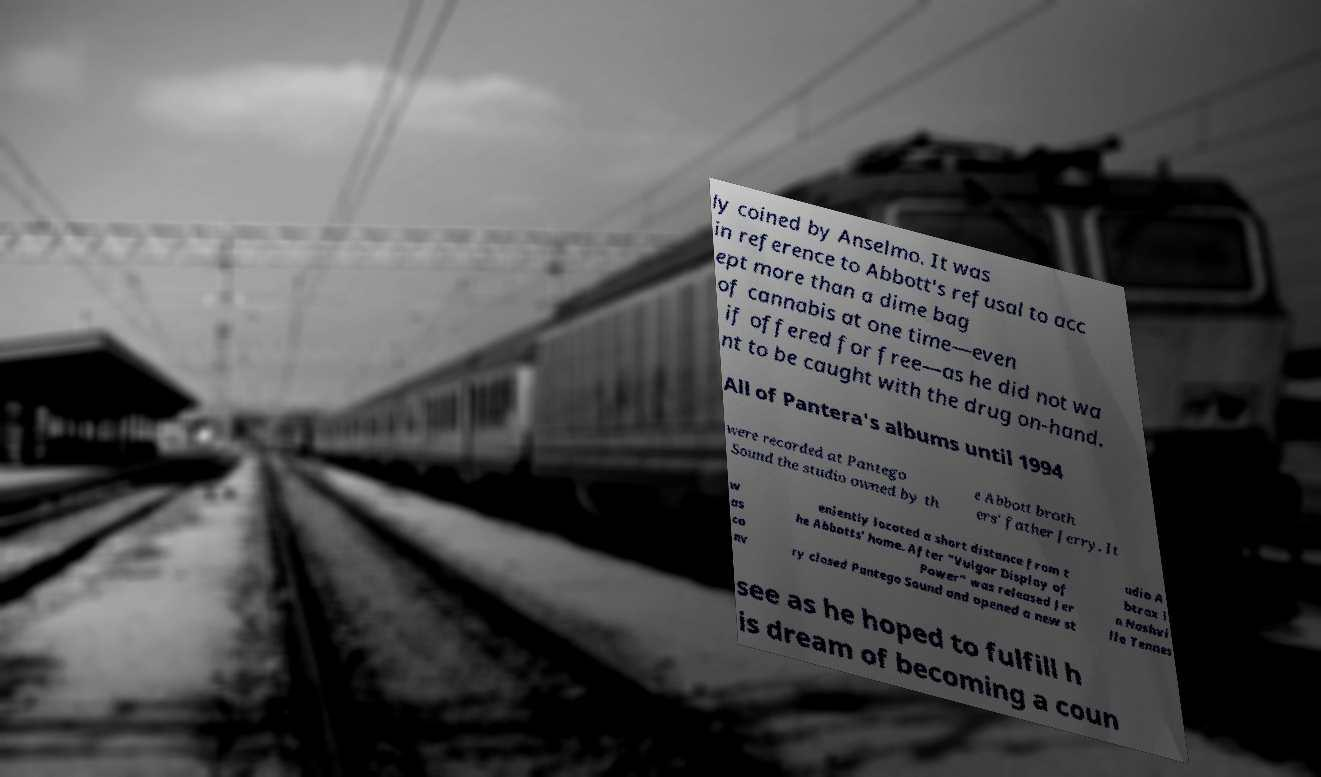Please read and relay the text visible in this image. What does it say? ly coined by Anselmo. It was in reference to Abbott's refusal to acc ept more than a dime bag of cannabis at one time—even if offered for free—as he did not wa nt to be caught with the drug on-hand. All of Pantera's albums until 1994 were recorded at Pantego Sound the studio owned by th e Abbott broth ers' father Jerry. It w as co nv eniently located a short distance from t he Abbotts' home. After "Vulgar Display of Power" was released Jer ry closed Pantego Sound and opened a new st udio A btrax i n Nashvi lle Tennes see as he hoped to fulfill h is dream of becoming a coun 